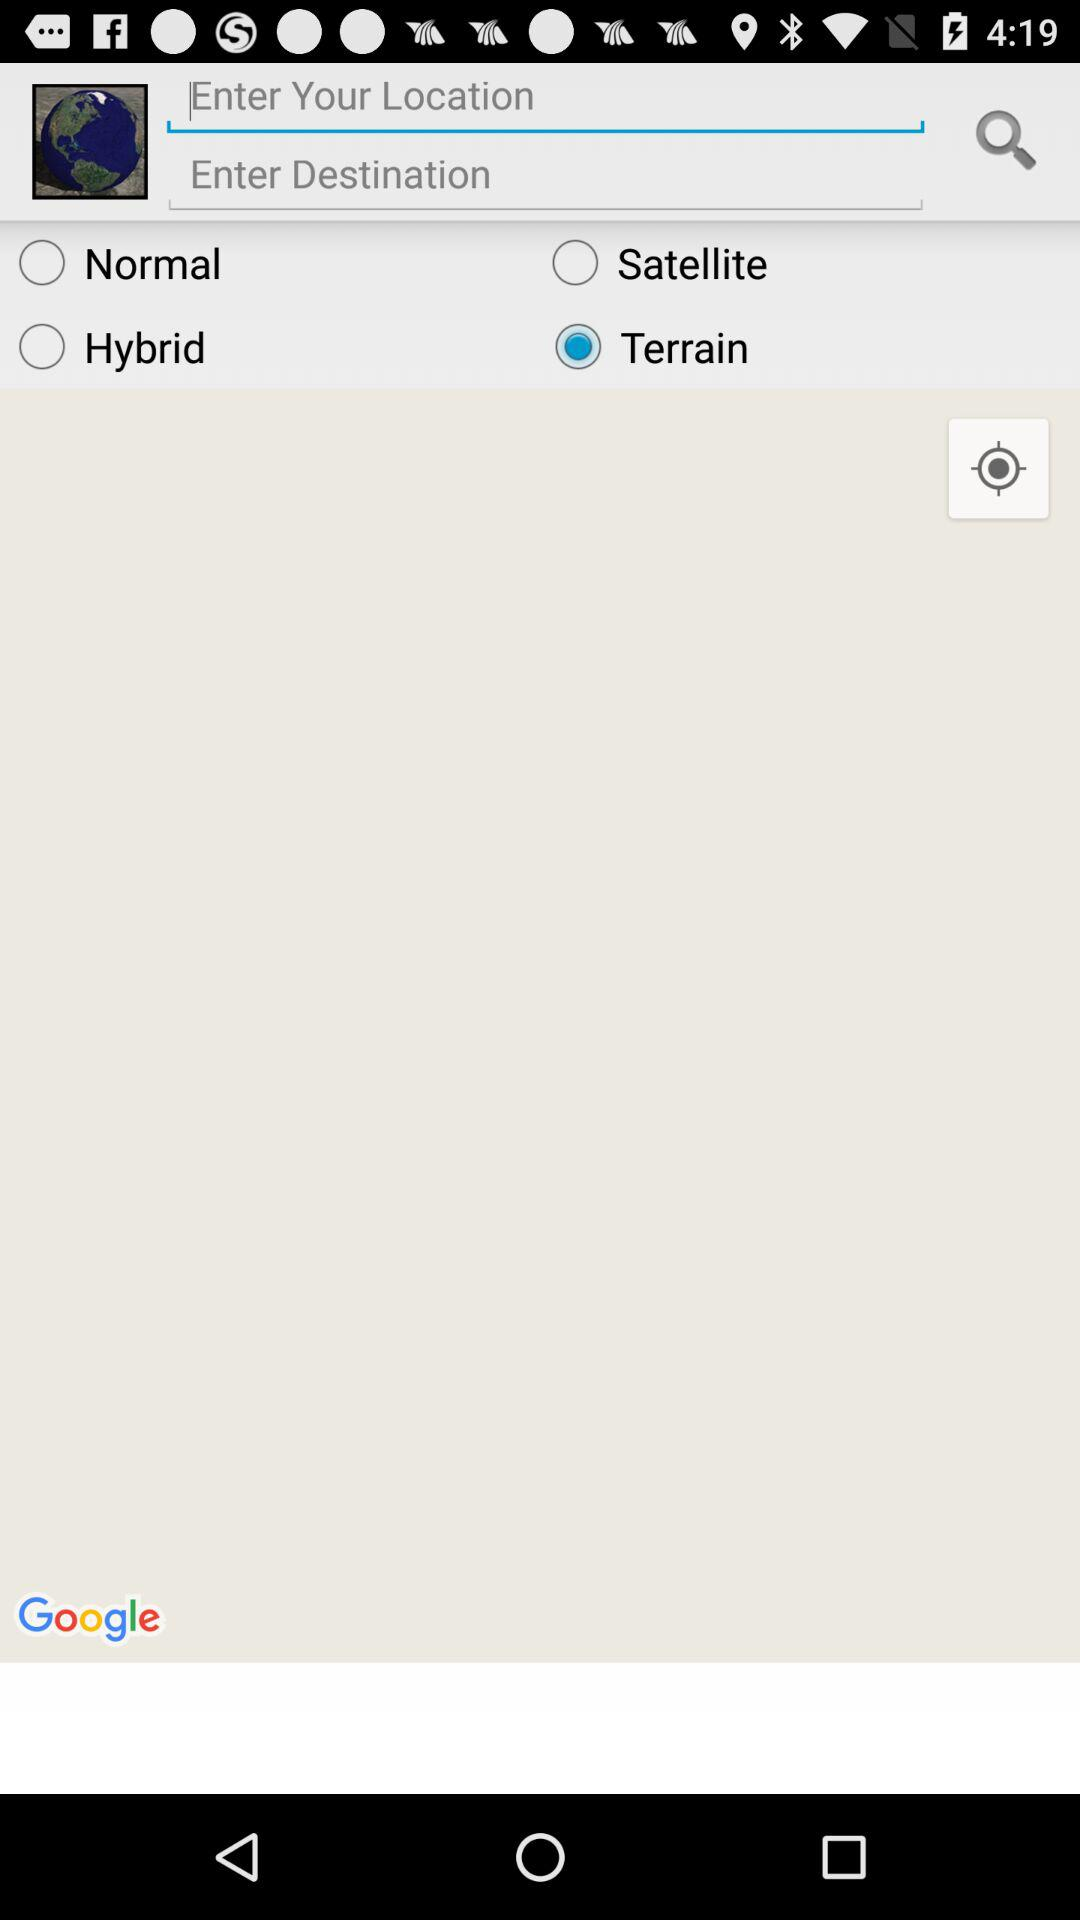Where is the user going?
When the provided information is insufficient, respond with <no answer>. <no answer> 